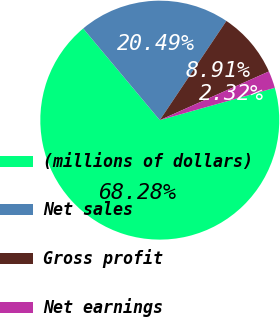Convert chart to OTSL. <chart><loc_0><loc_0><loc_500><loc_500><pie_chart><fcel>(millions of dollars)<fcel>Net sales<fcel>Gross profit<fcel>Net earnings<nl><fcel>68.28%<fcel>20.49%<fcel>8.91%<fcel>2.32%<nl></chart> 